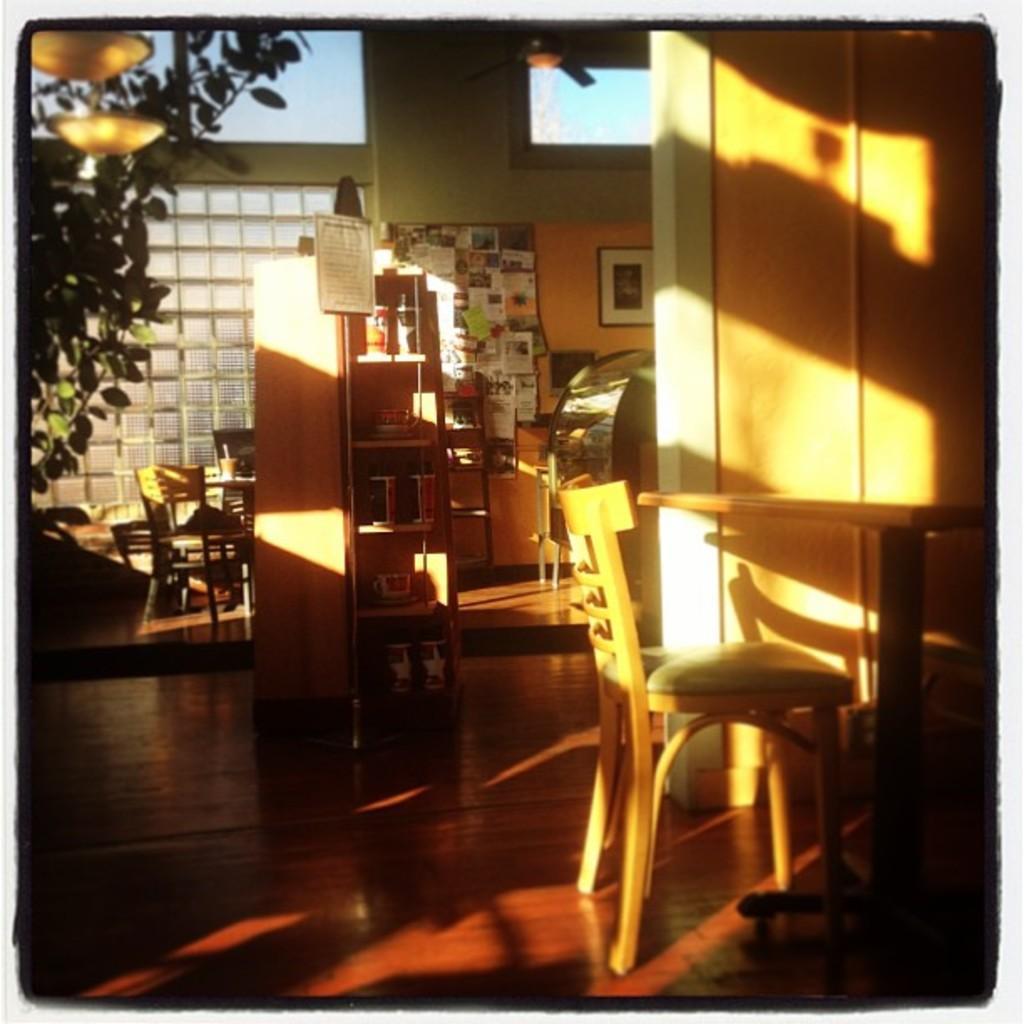Please provide a concise description of this image. This image is taken indoors. At the bottom of the image there is a floor. On the right side of the image there is a table and an empty chair. On the left side of the image there is a plant and there are two chairs and a table. In the middle of the image there is a cupboard with a few things. In the background there is a wall with a window and a picture frame. 